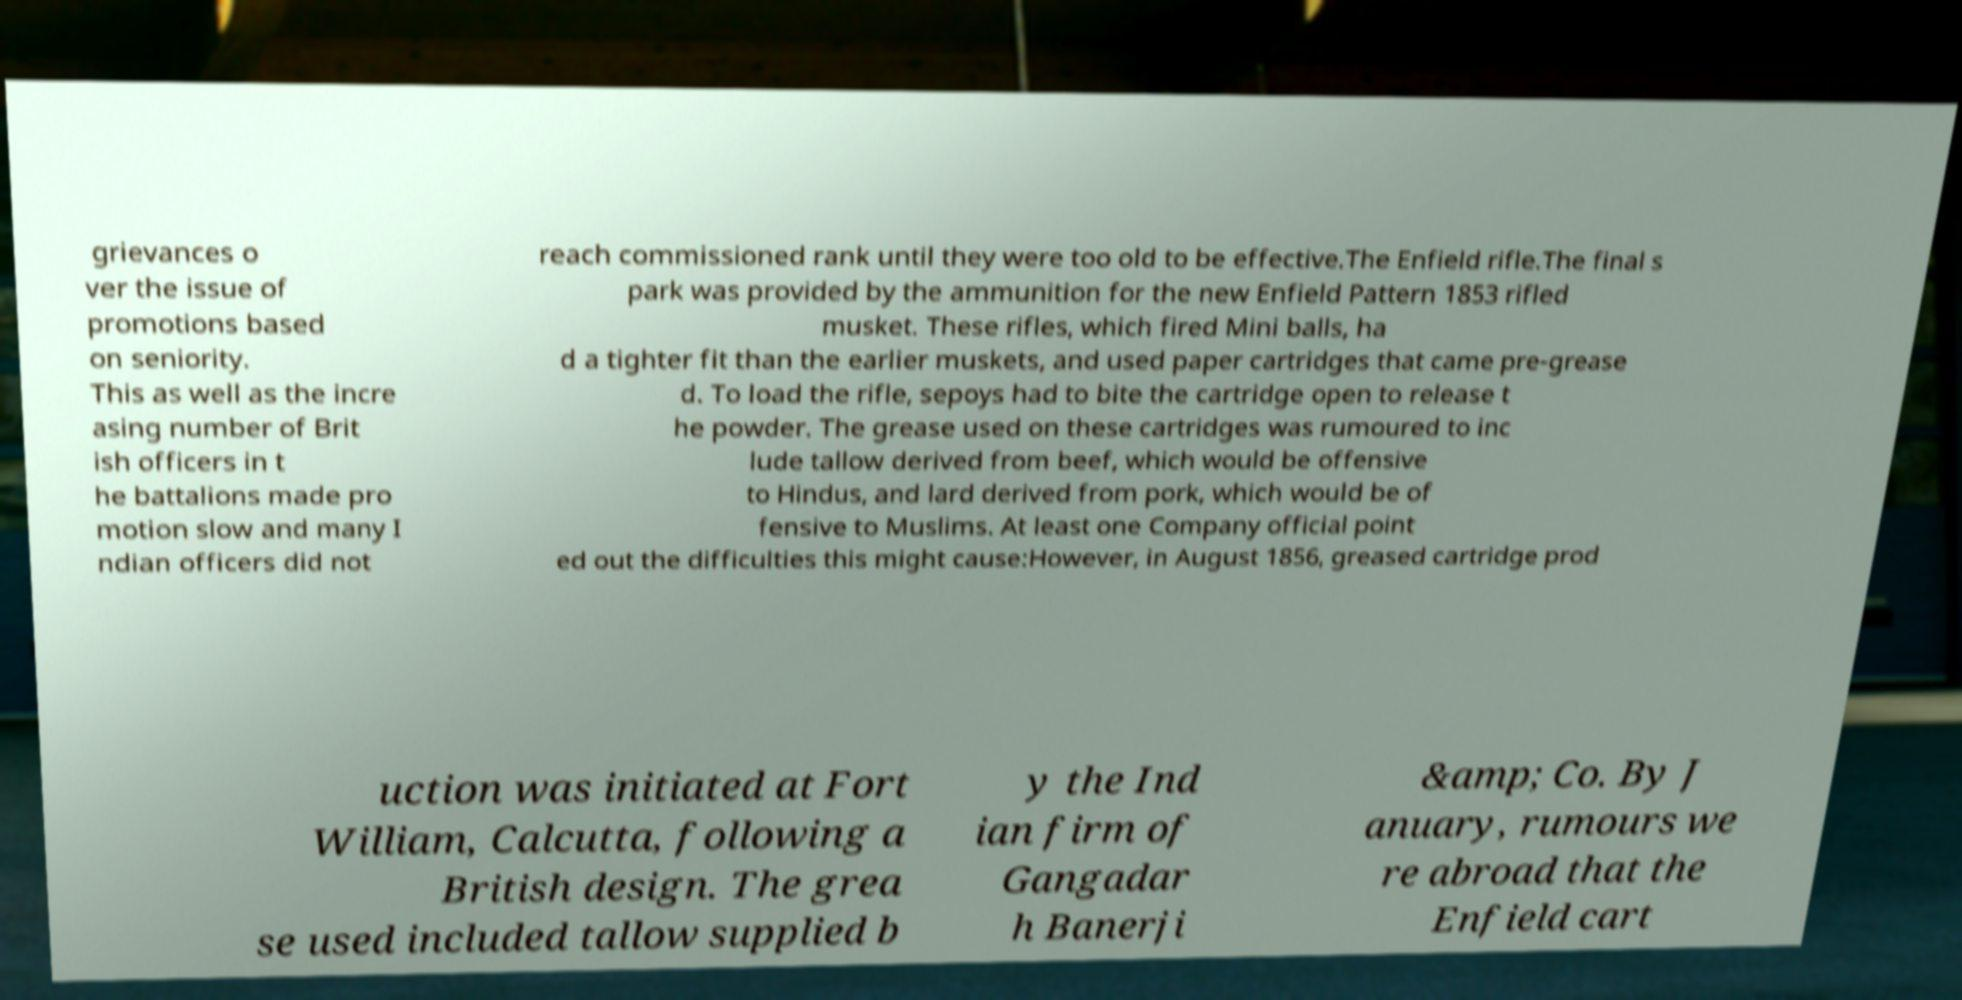Could you extract and type out the text from this image? grievances o ver the issue of promotions based on seniority. This as well as the incre asing number of Brit ish officers in t he battalions made pro motion slow and many I ndian officers did not reach commissioned rank until they were too old to be effective.The Enfield rifle.The final s park was provided by the ammunition for the new Enfield Pattern 1853 rifled musket. These rifles, which fired Mini balls, ha d a tighter fit than the earlier muskets, and used paper cartridges that came pre-grease d. To load the rifle, sepoys had to bite the cartridge open to release t he powder. The grease used on these cartridges was rumoured to inc lude tallow derived from beef, which would be offensive to Hindus, and lard derived from pork, which would be of fensive to Muslims. At least one Company official point ed out the difficulties this might cause:However, in August 1856, greased cartridge prod uction was initiated at Fort William, Calcutta, following a British design. The grea se used included tallow supplied b y the Ind ian firm of Gangadar h Banerji &amp; Co. By J anuary, rumours we re abroad that the Enfield cart 